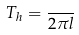<formula> <loc_0><loc_0><loc_500><loc_500>T _ { h } = \frac { } { 2 \pi l }</formula> 